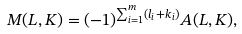Convert formula to latex. <formula><loc_0><loc_0><loc_500><loc_500>M ( L , K ) = ( - 1 ) ^ { \sum _ { i = 1 } ^ { m } ( l _ { i } + k _ { i } ) } A ( L , K ) ,</formula> 